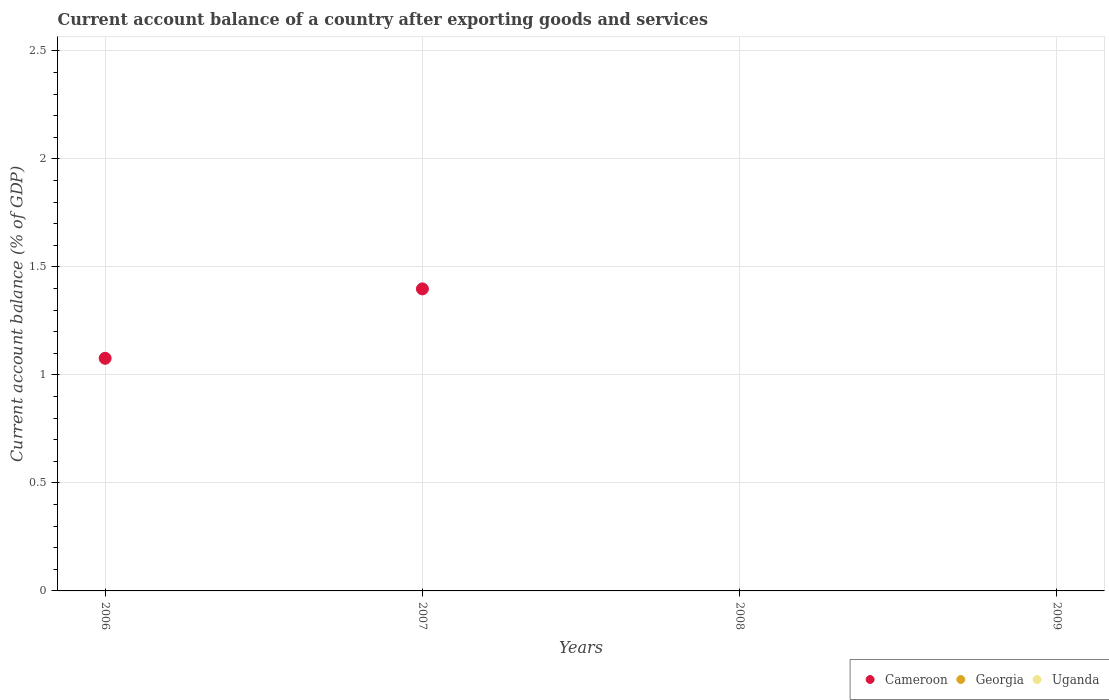How many different coloured dotlines are there?
Give a very brief answer. 1. What is the account balance in Uganda in 2007?
Provide a short and direct response. 0. Across all years, what is the maximum account balance in Cameroon?
Provide a short and direct response. 1.4. In which year was the account balance in Cameroon maximum?
Offer a very short reply. 2007. What is the total account balance in Georgia in the graph?
Offer a very short reply. 0. What is the ratio of the account balance in Cameroon in 2006 to that in 2007?
Offer a terse response. 0.77. Is the account balance in Cameroon in 2006 less than that in 2007?
Your response must be concise. Yes. What is the difference between the highest and the lowest account balance in Cameroon?
Give a very brief answer. 1.4. Does the account balance in Uganda monotonically increase over the years?
Keep it short and to the point. No. Is the account balance in Uganda strictly greater than the account balance in Cameroon over the years?
Ensure brevity in your answer.  No. Are the values on the major ticks of Y-axis written in scientific E-notation?
Give a very brief answer. No. Does the graph contain any zero values?
Make the answer very short. Yes. Does the graph contain grids?
Ensure brevity in your answer.  Yes. How are the legend labels stacked?
Provide a succinct answer. Horizontal. What is the title of the graph?
Ensure brevity in your answer.  Current account balance of a country after exporting goods and services. What is the label or title of the X-axis?
Your response must be concise. Years. What is the label or title of the Y-axis?
Provide a succinct answer. Current account balance (% of GDP). What is the Current account balance (% of GDP) of Cameroon in 2006?
Provide a succinct answer. 1.08. What is the Current account balance (% of GDP) of Uganda in 2006?
Provide a short and direct response. 0. What is the Current account balance (% of GDP) of Cameroon in 2007?
Provide a succinct answer. 1.4. What is the Current account balance (% of GDP) of Georgia in 2007?
Offer a very short reply. 0. What is the Current account balance (% of GDP) in Georgia in 2009?
Offer a terse response. 0. Across all years, what is the maximum Current account balance (% of GDP) in Cameroon?
Offer a very short reply. 1.4. Across all years, what is the minimum Current account balance (% of GDP) of Cameroon?
Offer a very short reply. 0. What is the total Current account balance (% of GDP) in Cameroon in the graph?
Offer a terse response. 2.48. What is the total Current account balance (% of GDP) in Georgia in the graph?
Your answer should be very brief. 0. What is the difference between the Current account balance (% of GDP) in Cameroon in 2006 and that in 2007?
Provide a short and direct response. -0.32. What is the average Current account balance (% of GDP) of Cameroon per year?
Your answer should be compact. 0.62. What is the average Current account balance (% of GDP) in Georgia per year?
Keep it short and to the point. 0. What is the average Current account balance (% of GDP) of Uganda per year?
Provide a succinct answer. 0. What is the ratio of the Current account balance (% of GDP) in Cameroon in 2006 to that in 2007?
Your response must be concise. 0.77. What is the difference between the highest and the lowest Current account balance (% of GDP) in Cameroon?
Make the answer very short. 1.4. 